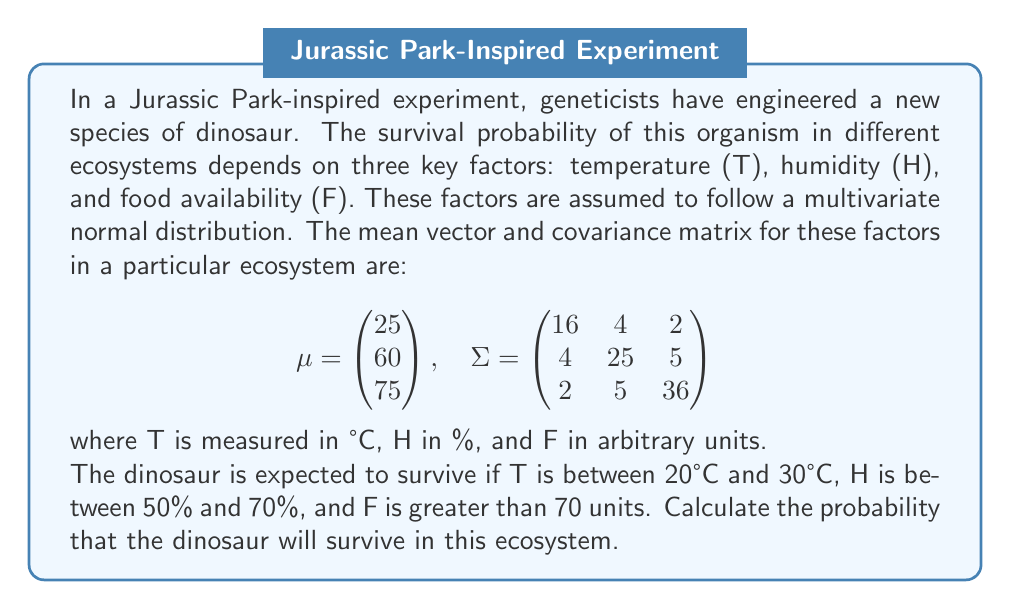Could you help me with this problem? To solve this problem, we need to use the multivariate normal distribution and calculate the probability that the three variables fall within the specified ranges simultaneously. This is a complex integration problem, but we can simplify it using the following steps:

1) First, we need to standardize the variables. For each variable, we calculate:

   $$Z = \frac{X - \mu}{\sigma}$$

2) For temperature (T):
   Lower bound: $Z_T = \frac{20 - 25}{4} = -1.25$
   Upper bound: $Z_T = \frac{30 - 25}{4} = 1.25$

3) For humidity (H):
   Lower bound: $Z_H = \frac{50 - 60}{5} = -2$
   Upper bound: $Z_H = \frac{70 - 60}{5} = 2$

4) For food availability (F):
   Lower bound: $Z_F = \frac{70 - 75}{6} = -0.833$
   Upper bound: $Z_F = \infty$

5) Now, we need to calculate the correlation matrix from the covariance matrix:

   $$R = \begin{pmatrix} 
   1 & 0.2 & 0.0833 \\
   0.2 & 1 & 0.1667 \\
   0.0833 & 0.1667 & 1
   \end{pmatrix}$$

6) The probability we're looking for is:

   $$P(-1.25 < Z_T < 1.25, -2 < Z_H < 2, Z_F > -0.833)$$

7) This probability can be calculated using numerical integration methods or specialized software for multivariate normal distributions.

8) Using such methods (e.g., R's pmvnorm function), we can calculate the probability.
Answer: The probability that the genetically engineered dinosaur will survive in this ecosystem is approximately 0.3912 or 39.12%. 